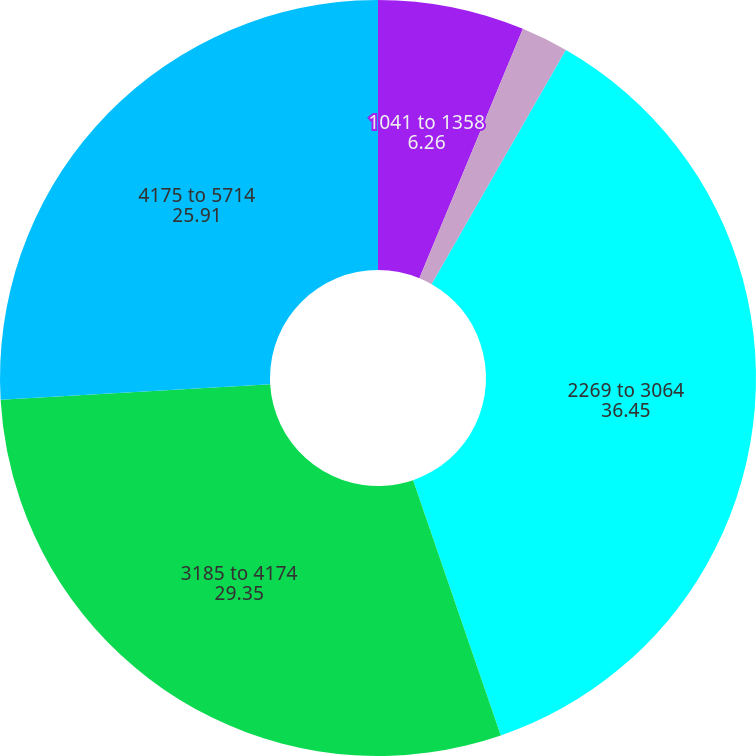Convert chart. <chart><loc_0><loc_0><loc_500><loc_500><pie_chart><fcel>1041 to 1358<fcel>1485 to 2072<fcel>2269 to 3064<fcel>3185 to 4174<fcel>4175 to 5714<nl><fcel>6.26%<fcel>2.02%<fcel>36.45%<fcel>29.35%<fcel>25.91%<nl></chart> 